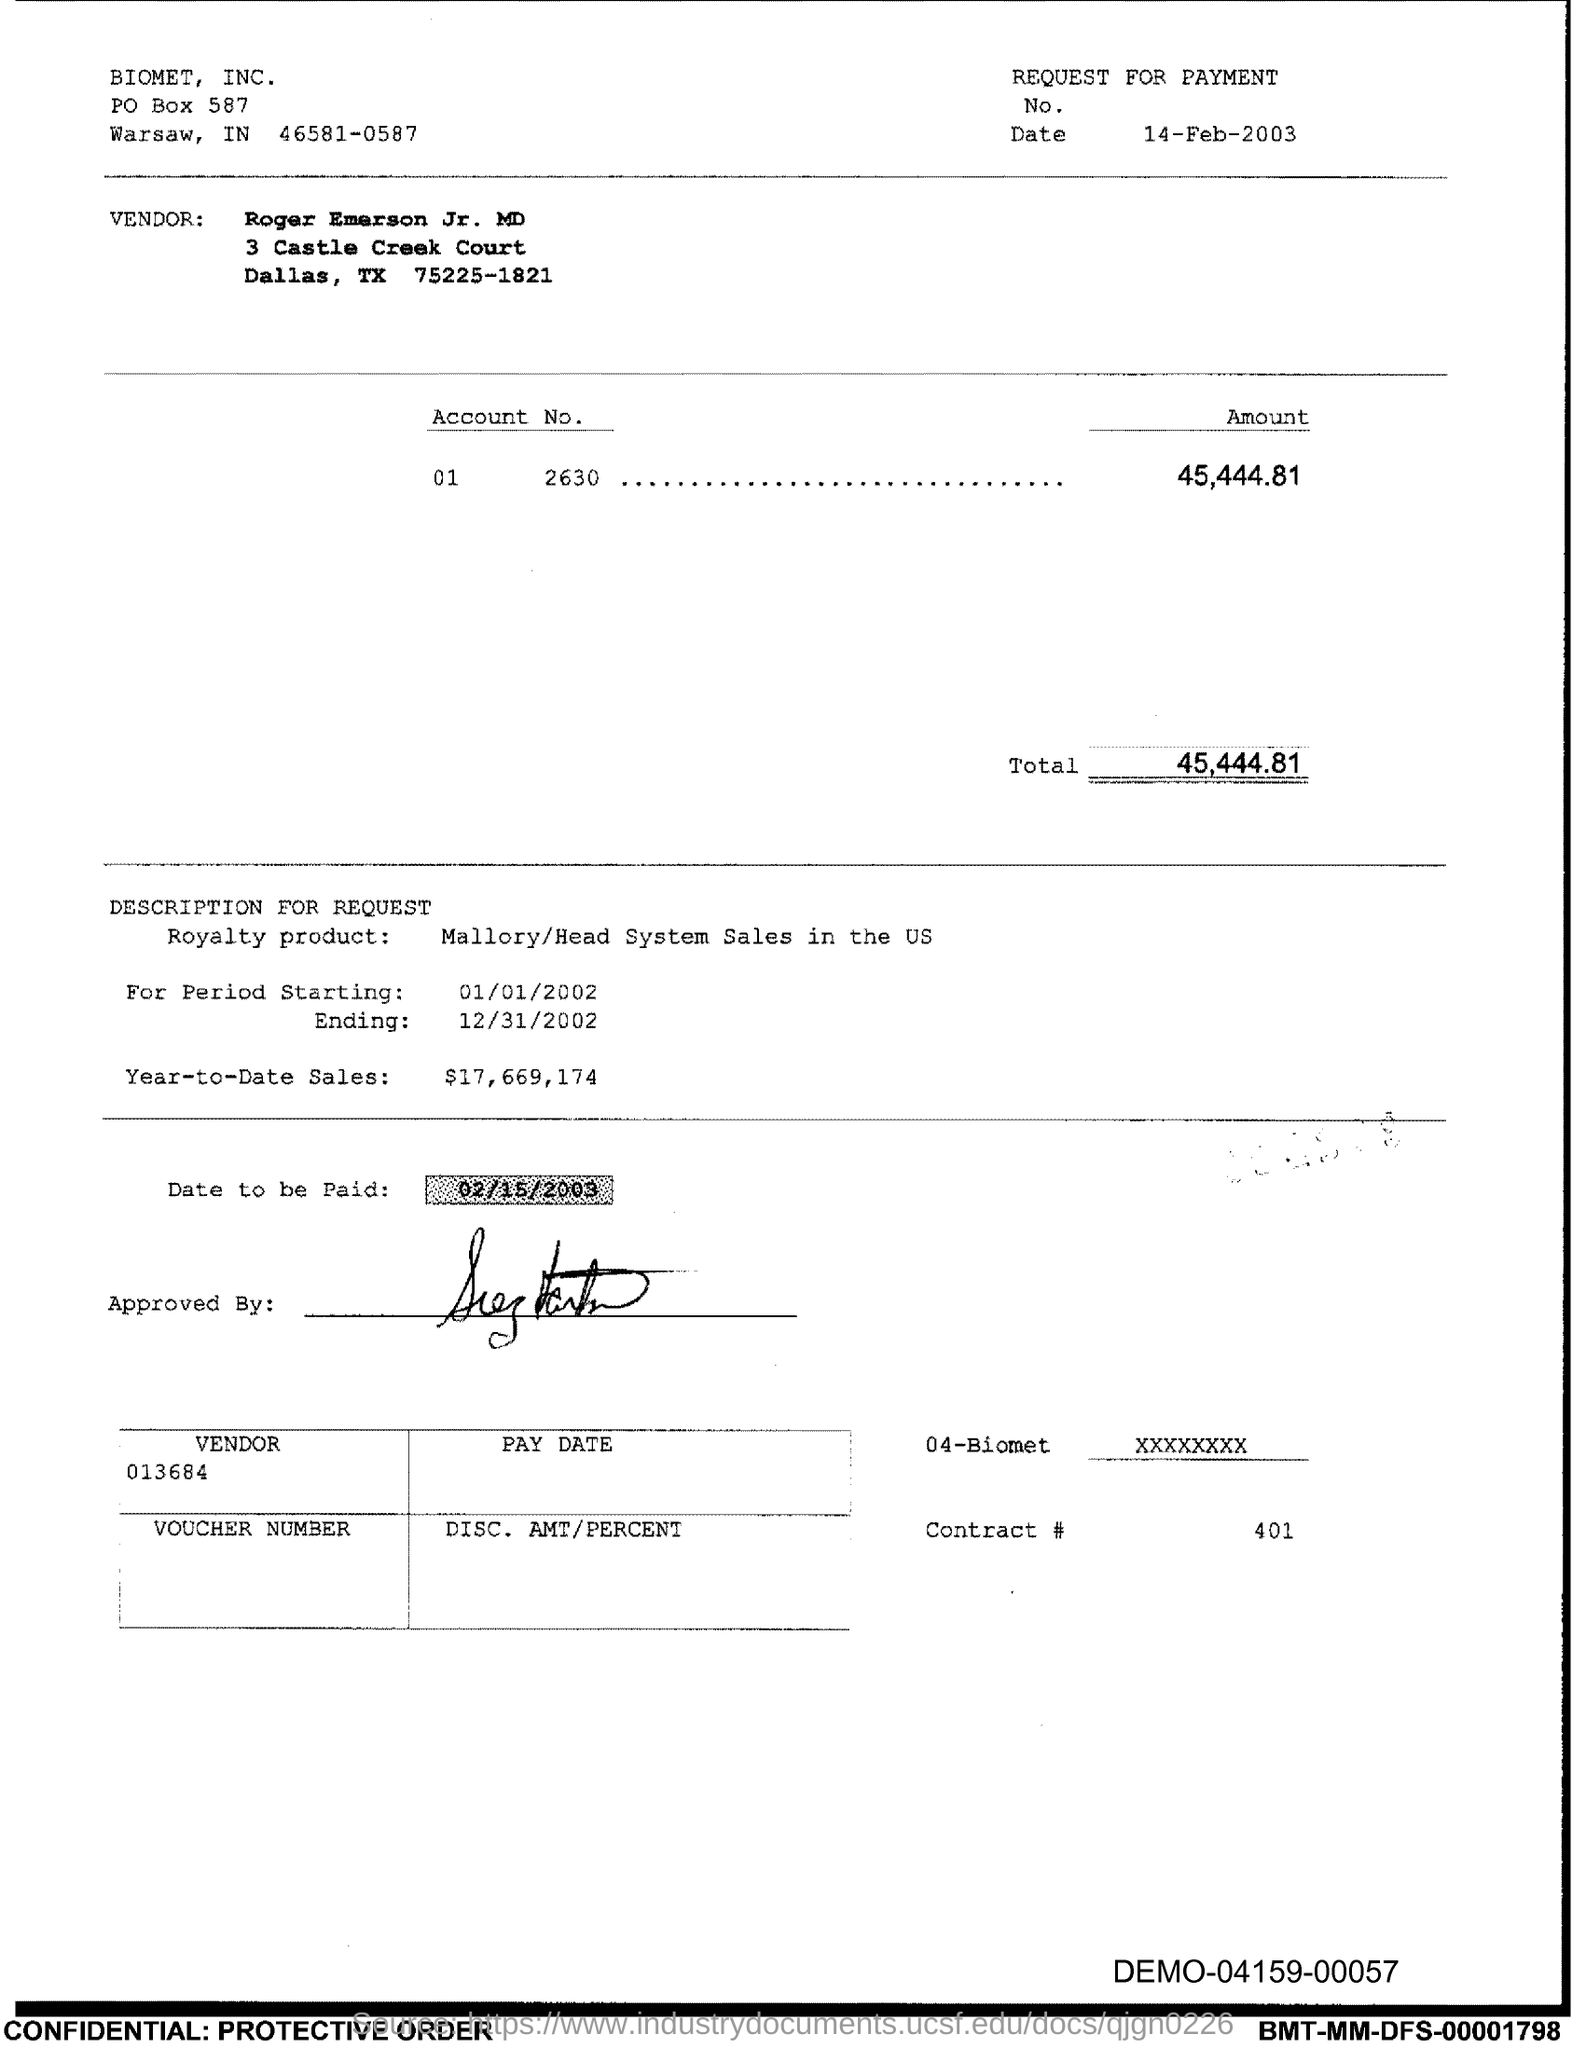What is the Contract # Number?
 401 